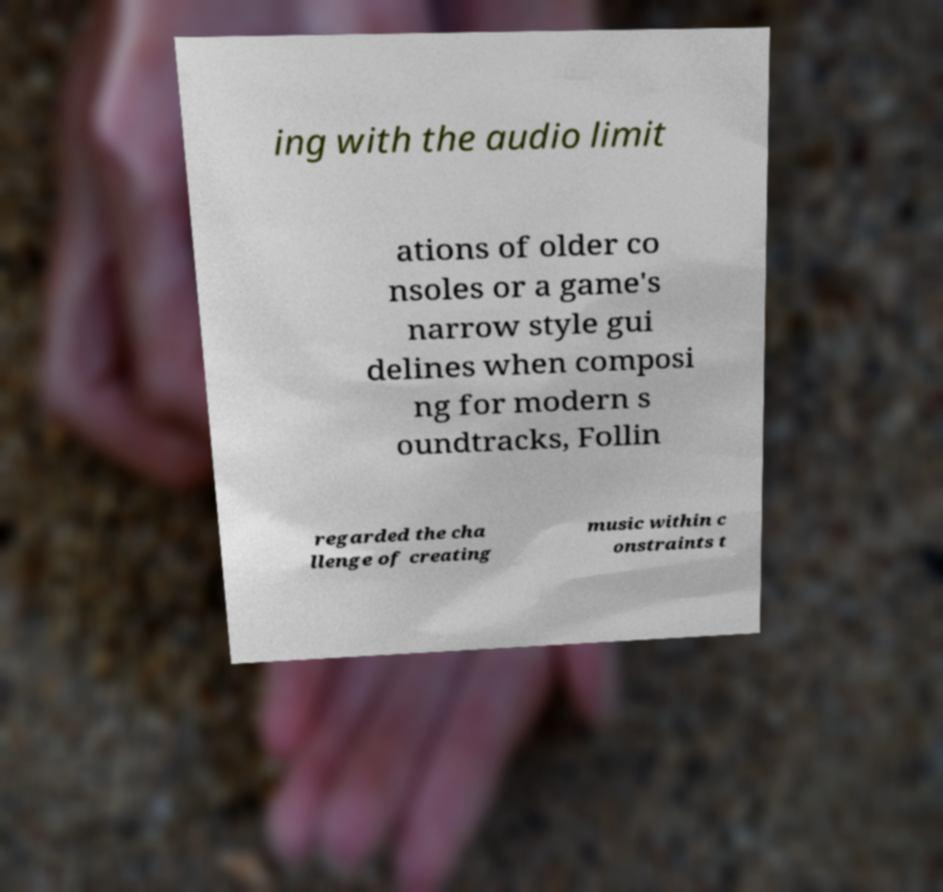What messages or text are displayed in this image? I need them in a readable, typed format. ing with the audio limit ations of older co nsoles or a game's narrow style gui delines when composi ng for modern s oundtracks, Follin regarded the cha llenge of creating music within c onstraints t 